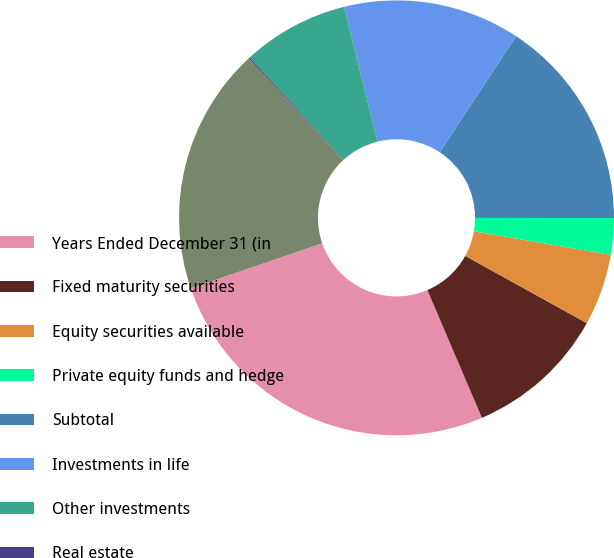Convert chart. <chart><loc_0><loc_0><loc_500><loc_500><pie_chart><fcel>Years Ended December 31 (in<fcel>Fixed maturity securities<fcel>Equity securities available<fcel>Private equity funds and hedge<fcel>Subtotal<fcel>Investments in life<fcel>Other investments<fcel>Real estate<fcel>Total<nl><fcel>26.17%<fcel>10.53%<fcel>5.32%<fcel>2.71%<fcel>15.75%<fcel>13.14%<fcel>7.92%<fcel>0.1%<fcel>18.35%<nl></chart> 